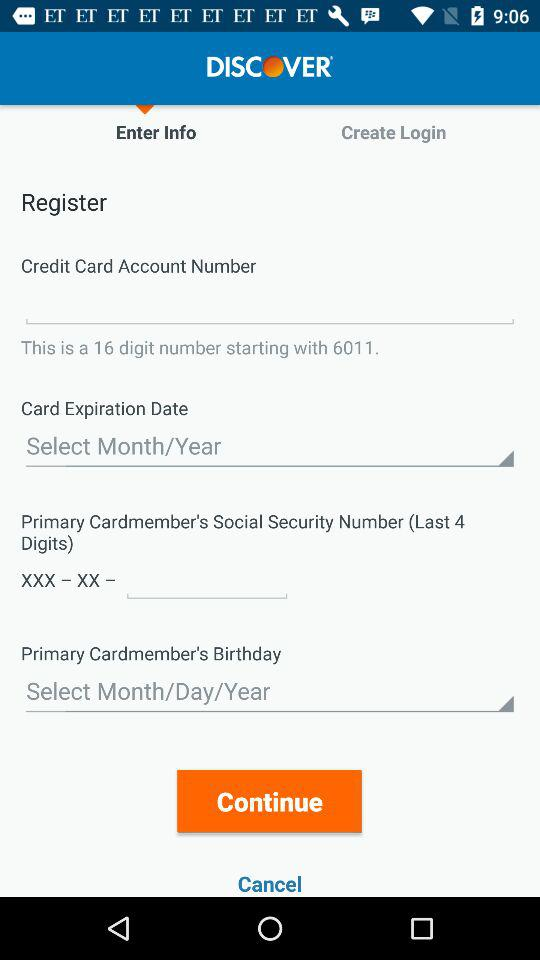Which tab am I on? You are on the "Enter Info" tab. 